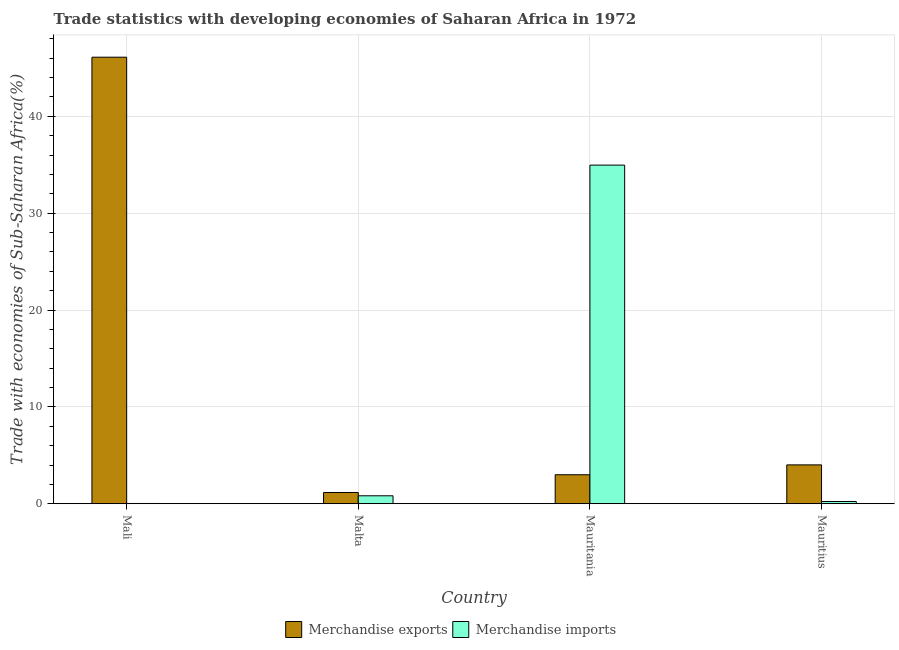How many different coloured bars are there?
Ensure brevity in your answer.  2. Are the number of bars on each tick of the X-axis equal?
Ensure brevity in your answer.  Yes. How many bars are there on the 3rd tick from the right?
Keep it short and to the point. 2. What is the label of the 1st group of bars from the left?
Offer a terse response. Mali. What is the merchandise exports in Mauritius?
Your answer should be compact. 4.01. Across all countries, what is the maximum merchandise imports?
Provide a short and direct response. 34.96. Across all countries, what is the minimum merchandise exports?
Your answer should be very brief. 1.16. In which country was the merchandise imports maximum?
Your answer should be compact. Mauritania. In which country was the merchandise imports minimum?
Offer a very short reply. Mali. What is the total merchandise exports in the graph?
Your answer should be very brief. 54.27. What is the difference between the merchandise exports in Mauritania and that in Mauritius?
Your answer should be compact. -1.02. What is the difference between the merchandise imports in Mauritania and the merchandise exports in Mauritius?
Your response must be concise. 30.95. What is the average merchandise exports per country?
Provide a succinct answer. 13.57. What is the difference between the merchandise exports and merchandise imports in Malta?
Give a very brief answer. 0.34. What is the ratio of the merchandise imports in Mali to that in Mauritius?
Provide a short and direct response. 0.12. Is the merchandise imports in Malta less than that in Mauritius?
Ensure brevity in your answer.  No. What is the difference between the highest and the second highest merchandise imports?
Offer a very short reply. 34.14. What is the difference between the highest and the lowest merchandise exports?
Make the answer very short. 44.94. In how many countries, is the merchandise imports greater than the average merchandise imports taken over all countries?
Your response must be concise. 1. Is the sum of the merchandise imports in Malta and Mauritania greater than the maximum merchandise exports across all countries?
Give a very brief answer. No. How many bars are there?
Offer a terse response. 8. Are the values on the major ticks of Y-axis written in scientific E-notation?
Provide a short and direct response. No. How are the legend labels stacked?
Give a very brief answer. Horizontal. What is the title of the graph?
Provide a succinct answer. Trade statistics with developing economies of Saharan Africa in 1972. What is the label or title of the X-axis?
Offer a very short reply. Country. What is the label or title of the Y-axis?
Offer a terse response. Trade with economies of Sub-Saharan Africa(%). What is the Trade with economies of Sub-Saharan Africa(%) in Merchandise exports in Mali?
Keep it short and to the point. 46.1. What is the Trade with economies of Sub-Saharan Africa(%) in Merchandise imports in Mali?
Your response must be concise. 0.03. What is the Trade with economies of Sub-Saharan Africa(%) of Merchandise exports in Malta?
Make the answer very short. 1.16. What is the Trade with economies of Sub-Saharan Africa(%) in Merchandise imports in Malta?
Your answer should be very brief. 0.82. What is the Trade with economies of Sub-Saharan Africa(%) of Merchandise exports in Mauritania?
Offer a very short reply. 2.99. What is the Trade with economies of Sub-Saharan Africa(%) in Merchandise imports in Mauritania?
Give a very brief answer. 34.96. What is the Trade with economies of Sub-Saharan Africa(%) in Merchandise exports in Mauritius?
Give a very brief answer. 4.01. What is the Trade with economies of Sub-Saharan Africa(%) in Merchandise imports in Mauritius?
Your response must be concise. 0.23. Across all countries, what is the maximum Trade with economies of Sub-Saharan Africa(%) in Merchandise exports?
Give a very brief answer. 46.1. Across all countries, what is the maximum Trade with economies of Sub-Saharan Africa(%) in Merchandise imports?
Offer a terse response. 34.96. Across all countries, what is the minimum Trade with economies of Sub-Saharan Africa(%) of Merchandise exports?
Your answer should be very brief. 1.16. Across all countries, what is the minimum Trade with economies of Sub-Saharan Africa(%) of Merchandise imports?
Your answer should be compact. 0.03. What is the total Trade with economies of Sub-Saharan Africa(%) of Merchandise exports in the graph?
Keep it short and to the point. 54.27. What is the total Trade with economies of Sub-Saharan Africa(%) of Merchandise imports in the graph?
Give a very brief answer. 36.04. What is the difference between the Trade with economies of Sub-Saharan Africa(%) in Merchandise exports in Mali and that in Malta?
Give a very brief answer. 44.94. What is the difference between the Trade with economies of Sub-Saharan Africa(%) in Merchandise imports in Mali and that in Malta?
Your answer should be compact. -0.79. What is the difference between the Trade with economies of Sub-Saharan Africa(%) of Merchandise exports in Mali and that in Mauritania?
Offer a terse response. 43.11. What is the difference between the Trade with economies of Sub-Saharan Africa(%) of Merchandise imports in Mali and that in Mauritania?
Keep it short and to the point. -34.93. What is the difference between the Trade with economies of Sub-Saharan Africa(%) of Merchandise exports in Mali and that in Mauritius?
Your response must be concise. 42.09. What is the difference between the Trade with economies of Sub-Saharan Africa(%) of Merchandise imports in Mali and that in Mauritius?
Offer a terse response. -0.21. What is the difference between the Trade with economies of Sub-Saharan Africa(%) in Merchandise exports in Malta and that in Mauritania?
Offer a very short reply. -1.83. What is the difference between the Trade with economies of Sub-Saharan Africa(%) of Merchandise imports in Malta and that in Mauritania?
Offer a terse response. -34.14. What is the difference between the Trade with economies of Sub-Saharan Africa(%) in Merchandise exports in Malta and that in Mauritius?
Keep it short and to the point. -2.85. What is the difference between the Trade with economies of Sub-Saharan Africa(%) in Merchandise imports in Malta and that in Mauritius?
Ensure brevity in your answer.  0.59. What is the difference between the Trade with economies of Sub-Saharan Africa(%) in Merchandise exports in Mauritania and that in Mauritius?
Offer a terse response. -1.02. What is the difference between the Trade with economies of Sub-Saharan Africa(%) in Merchandise imports in Mauritania and that in Mauritius?
Offer a terse response. 34.73. What is the difference between the Trade with economies of Sub-Saharan Africa(%) of Merchandise exports in Mali and the Trade with economies of Sub-Saharan Africa(%) of Merchandise imports in Malta?
Provide a short and direct response. 45.28. What is the difference between the Trade with economies of Sub-Saharan Africa(%) in Merchandise exports in Mali and the Trade with economies of Sub-Saharan Africa(%) in Merchandise imports in Mauritania?
Provide a short and direct response. 11.14. What is the difference between the Trade with economies of Sub-Saharan Africa(%) of Merchandise exports in Mali and the Trade with economies of Sub-Saharan Africa(%) of Merchandise imports in Mauritius?
Provide a succinct answer. 45.87. What is the difference between the Trade with economies of Sub-Saharan Africa(%) in Merchandise exports in Malta and the Trade with economies of Sub-Saharan Africa(%) in Merchandise imports in Mauritania?
Your answer should be very brief. -33.8. What is the difference between the Trade with economies of Sub-Saharan Africa(%) in Merchandise exports in Malta and the Trade with economies of Sub-Saharan Africa(%) in Merchandise imports in Mauritius?
Offer a very short reply. 0.93. What is the difference between the Trade with economies of Sub-Saharan Africa(%) of Merchandise exports in Mauritania and the Trade with economies of Sub-Saharan Africa(%) of Merchandise imports in Mauritius?
Give a very brief answer. 2.76. What is the average Trade with economies of Sub-Saharan Africa(%) in Merchandise exports per country?
Offer a very short reply. 13.57. What is the average Trade with economies of Sub-Saharan Africa(%) of Merchandise imports per country?
Keep it short and to the point. 9.01. What is the difference between the Trade with economies of Sub-Saharan Africa(%) of Merchandise exports and Trade with economies of Sub-Saharan Africa(%) of Merchandise imports in Mali?
Give a very brief answer. 46.07. What is the difference between the Trade with economies of Sub-Saharan Africa(%) of Merchandise exports and Trade with economies of Sub-Saharan Africa(%) of Merchandise imports in Malta?
Give a very brief answer. 0.34. What is the difference between the Trade with economies of Sub-Saharan Africa(%) of Merchandise exports and Trade with economies of Sub-Saharan Africa(%) of Merchandise imports in Mauritania?
Offer a terse response. -31.97. What is the difference between the Trade with economies of Sub-Saharan Africa(%) of Merchandise exports and Trade with economies of Sub-Saharan Africa(%) of Merchandise imports in Mauritius?
Ensure brevity in your answer.  3.78. What is the ratio of the Trade with economies of Sub-Saharan Africa(%) in Merchandise exports in Mali to that in Malta?
Offer a terse response. 39.69. What is the ratio of the Trade with economies of Sub-Saharan Africa(%) of Merchandise imports in Mali to that in Malta?
Your answer should be compact. 0.03. What is the ratio of the Trade with economies of Sub-Saharan Africa(%) of Merchandise exports in Mali to that in Mauritania?
Ensure brevity in your answer.  15.4. What is the ratio of the Trade with economies of Sub-Saharan Africa(%) of Merchandise imports in Mali to that in Mauritania?
Keep it short and to the point. 0. What is the ratio of the Trade with economies of Sub-Saharan Africa(%) in Merchandise exports in Mali to that in Mauritius?
Offer a very short reply. 11.49. What is the ratio of the Trade with economies of Sub-Saharan Africa(%) in Merchandise imports in Mali to that in Mauritius?
Your answer should be very brief. 0.12. What is the ratio of the Trade with economies of Sub-Saharan Africa(%) in Merchandise exports in Malta to that in Mauritania?
Ensure brevity in your answer.  0.39. What is the ratio of the Trade with economies of Sub-Saharan Africa(%) of Merchandise imports in Malta to that in Mauritania?
Offer a terse response. 0.02. What is the ratio of the Trade with economies of Sub-Saharan Africa(%) of Merchandise exports in Malta to that in Mauritius?
Make the answer very short. 0.29. What is the ratio of the Trade with economies of Sub-Saharan Africa(%) of Merchandise imports in Malta to that in Mauritius?
Ensure brevity in your answer.  3.53. What is the ratio of the Trade with economies of Sub-Saharan Africa(%) in Merchandise exports in Mauritania to that in Mauritius?
Your response must be concise. 0.75. What is the ratio of the Trade with economies of Sub-Saharan Africa(%) of Merchandise imports in Mauritania to that in Mauritius?
Make the answer very short. 149.99. What is the difference between the highest and the second highest Trade with economies of Sub-Saharan Africa(%) of Merchandise exports?
Offer a terse response. 42.09. What is the difference between the highest and the second highest Trade with economies of Sub-Saharan Africa(%) in Merchandise imports?
Your response must be concise. 34.14. What is the difference between the highest and the lowest Trade with economies of Sub-Saharan Africa(%) in Merchandise exports?
Your response must be concise. 44.94. What is the difference between the highest and the lowest Trade with economies of Sub-Saharan Africa(%) in Merchandise imports?
Your answer should be compact. 34.93. 